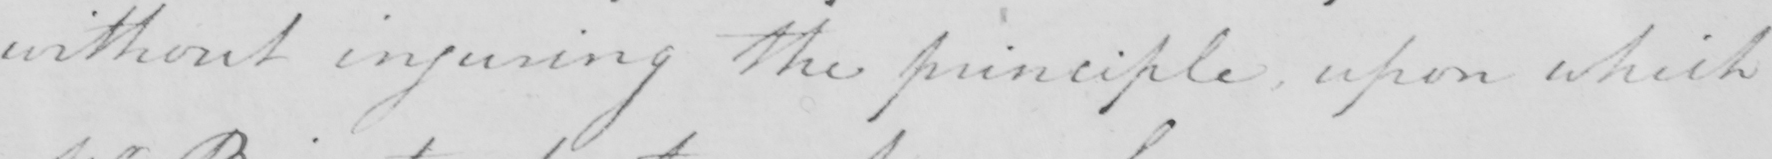What does this handwritten line say? without injuring the principle , upon which 